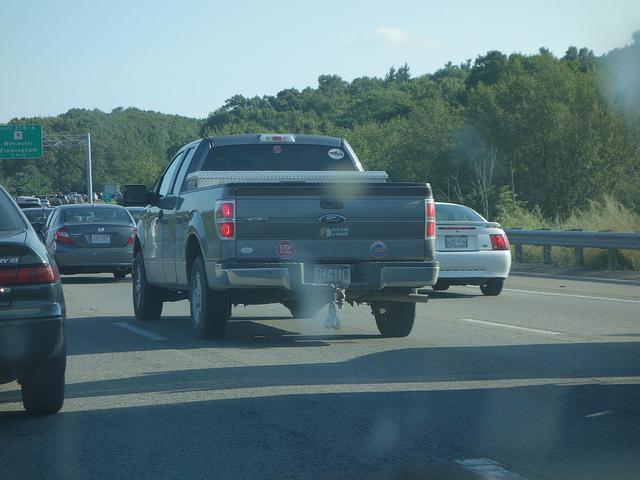How many cars can you see?
Give a very brief answer. 3. 